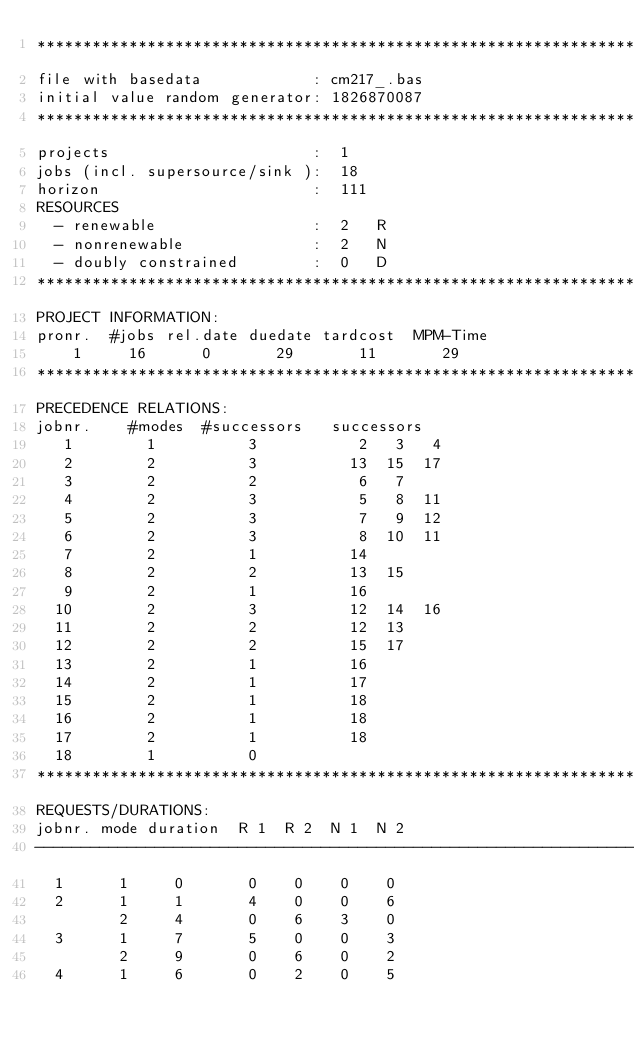Convert code to text. <code><loc_0><loc_0><loc_500><loc_500><_ObjectiveC_>************************************************************************
file with basedata            : cm217_.bas
initial value random generator: 1826870087
************************************************************************
projects                      :  1
jobs (incl. supersource/sink ):  18
horizon                       :  111
RESOURCES
  - renewable                 :  2   R
  - nonrenewable              :  2   N
  - doubly constrained        :  0   D
************************************************************************
PROJECT INFORMATION:
pronr.  #jobs rel.date duedate tardcost  MPM-Time
    1     16      0       29       11       29
************************************************************************
PRECEDENCE RELATIONS:
jobnr.    #modes  #successors   successors
   1        1          3           2   3   4
   2        2          3          13  15  17
   3        2          2           6   7
   4        2          3           5   8  11
   5        2          3           7   9  12
   6        2          3           8  10  11
   7        2          1          14
   8        2          2          13  15
   9        2          1          16
  10        2          3          12  14  16
  11        2          2          12  13
  12        2          2          15  17
  13        2          1          16
  14        2          1          17
  15        2          1          18
  16        2          1          18
  17        2          1          18
  18        1          0        
************************************************************************
REQUESTS/DURATIONS:
jobnr. mode duration  R 1  R 2  N 1  N 2
------------------------------------------------------------------------
  1      1     0       0    0    0    0
  2      1     1       4    0    0    6
         2     4       0    6    3    0
  3      1     7       5    0    0    3
         2     9       0    6    0    2
  4      1     6       0    2    0    5</code> 